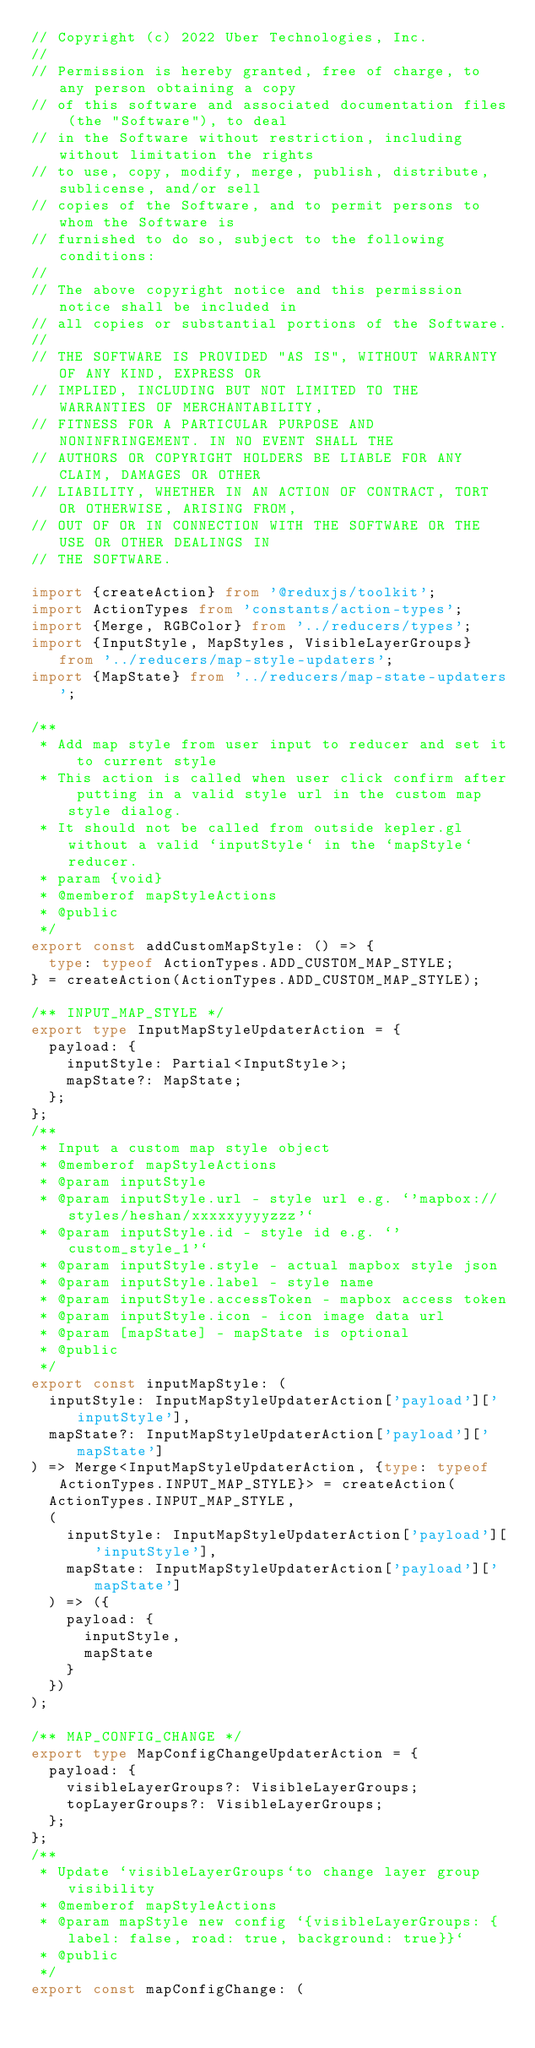Convert code to text. <code><loc_0><loc_0><loc_500><loc_500><_TypeScript_>// Copyright (c) 2022 Uber Technologies, Inc.
//
// Permission is hereby granted, free of charge, to any person obtaining a copy
// of this software and associated documentation files (the "Software"), to deal
// in the Software without restriction, including without limitation the rights
// to use, copy, modify, merge, publish, distribute, sublicense, and/or sell
// copies of the Software, and to permit persons to whom the Software is
// furnished to do so, subject to the following conditions:
//
// The above copyright notice and this permission notice shall be included in
// all copies or substantial portions of the Software.
//
// THE SOFTWARE IS PROVIDED "AS IS", WITHOUT WARRANTY OF ANY KIND, EXPRESS OR
// IMPLIED, INCLUDING BUT NOT LIMITED TO THE WARRANTIES OF MERCHANTABILITY,
// FITNESS FOR A PARTICULAR PURPOSE AND NONINFRINGEMENT. IN NO EVENT SHALL THE
// AUTHORS OR COPYRIGHT HOLDERS BE LIABLE FOR ANY CLAIM, DAMAGES OR OTHER
// LIABILITY, WHETHER IN AN ACTION OF CONTRACT, TORT OR OTHERWISE, ARISING FROM,
// OUT OF OR IN CONNECTION WITH THE SOFTWARE OR THE USE OR OTHER DEALINGS IN
// THE SOFTWARE.

import {createAction} from '@reduxjs/toolkit';
import ActionTypes from 'constants/action-types';
import {Merge, RGBColor} from '../reducers/types';
import {InputStyle, MapStyles, VisibleLayerGroups} from '../reducers/map-style-updaters';
import {MapState} from '../reducers/map-state-updaters';

/**
 * Add map style from user input to reducer and set it to current style
 * This action is called when user click confirm after putting in a valid style url in the custom map style dialog.
 * It should not be called from outside kepler.gl without a valid `inputStyle` in the `mapStyle` reducer.
 * param {void}
 * @memberof mapStyleActions
 * @public
 */
export const addCustomMapStyle: () => {
  type: typeof ActionTypes.ADD_CUSTOM_MAP_STYLE;
} = createAction(ActionTypes.ADD_CUSTOM_MAP_STYLE);

/** INPUT_MAP_STYLE */
export type InputMapStyleUpdaterAction = {
  payload: {
    inputStyle: Partial<InputStyle>;
    mapState?: MapState;
  };
};
/**
 * Input a custom map style object
 * @memberof mapStyleActions
 * @param inputStyle
 * @param inputStyle.url - style url e.g. `'mapbox://styles/heshan/xxxxxyyyyzzz'`
 * @param inputStyle.id - style id e.g. `'custom_style_1'`
 * @param inputStyle.style - actual mapbox style json
 * @param inputStyle.label - style name
 * @param inputStyle.accessToken - mapbox access token
 * @param inputStyle.icon - icon image data url
 * @param [mapState] - mapState is optional
 * @public
 */
export const inputMapStyle: (
  inputStyle: InputMapStyleUpdaterAction['payload']['inputStyle'],
  mapState?: InputMapStyleUpdaterAction['payload']['mapState']
) => Merge<InputMapStyleUpdaterAction, {type: typeof ActionTypes.INPUT_MAP_STYLE}> = createAction(
  ActionTypes.INPUT_MAP_STYLE,
  (
    inputStyle: InputMapStyleUpdaterAction['payload']['inputStyle'],
    mapState: InputMapStyleUpdaterAction['payload']['mapState']
  ) => ({
    payload: {
      inputStyle,
      mapState
    }
  })
);

/** MAP_CONFIG_CHANGE */
export type MapConfigChangeUpdaterAction = {
  payload: {
    visibleLayerGroups?: VisibleLayerGroups;
    topLayerGroups?: VisibleLayerGroups;
  };
};
/**
 * Update `visibleLayerGroups`to change layer group visibility
 * @memberof mapStyleActions
 * @param mapStyle new config `{visibleLayerGroups: {label: false, road: true, background: true}}`
 * @public
 */
export const mapConfigChange: (</code> 